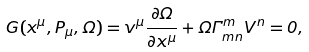<formula> <loc_0><loc_0><loc_500><loc_500>G ( x ^ { \mu } , P _ { \mu } , \Omega ) = v ^ { \mu } \frac { \partial \Omega } { \partial x ^ { \mu } } + \Omega \Gamma ^ { m } _ { m n } V ^ { n } = 0 ,</formula> 